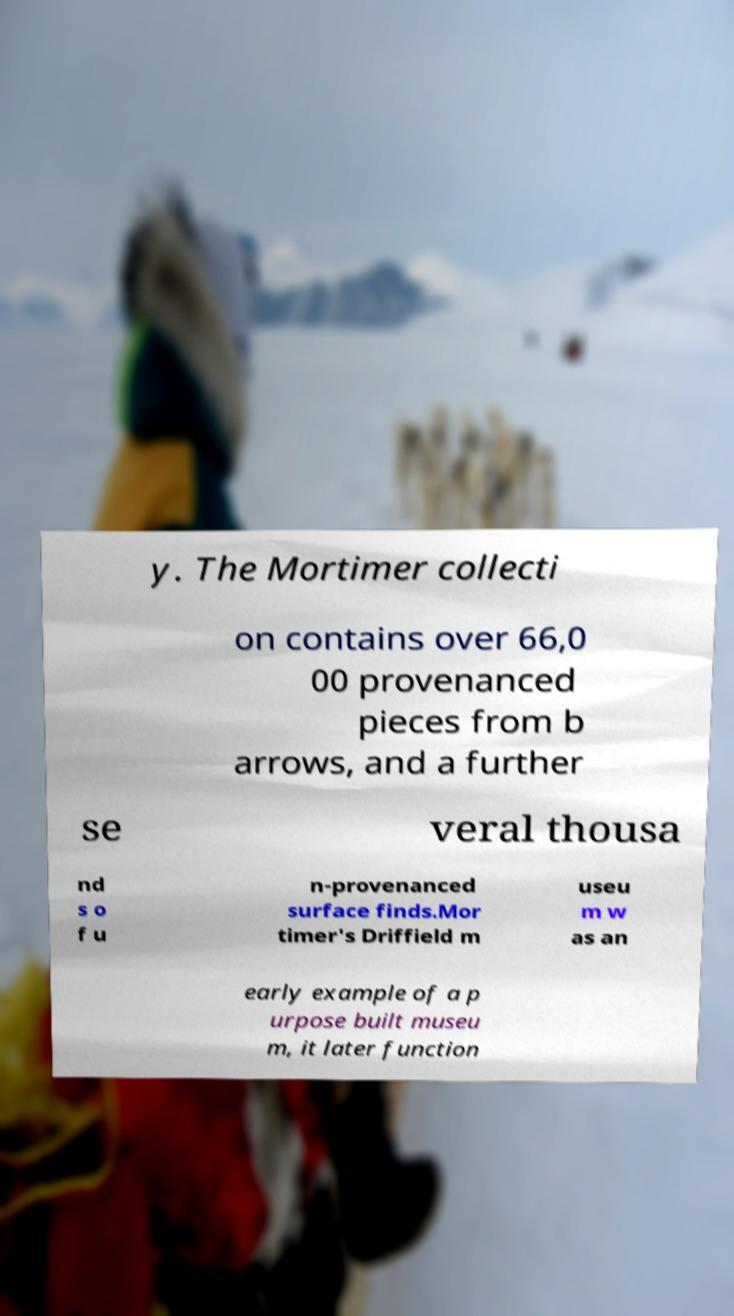Please read and relay the text visible in this image. What does it say? y. The Mortimer collecti on contains over 66,0 00 provenanced pieces from b arrows, and a further se veral thousa nd s o f u n-provenanced surface finds.Mor timer's Driffield m useu m w as an early example of a p urpose built museu m, it later function 